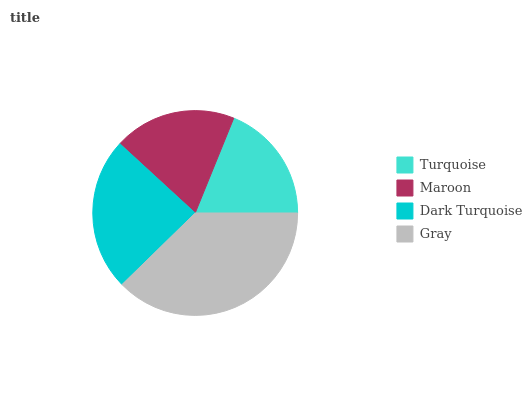Is Turquoise the minimum?
Answer yes or no. Yes. Is Gray the maximum?
Answer yes or no. Yes. Is Maroon the minimum?
Answer yes or no. No. Is Maroon the maximum?
Answer yes or no. No. Is Maroon greater than Turquoise?
Answer yes or no. Yes. Is Turquoise less than Maroon?
Answer yes or no. Yes. Is Turquoise greater than Maroon?
Answer yes or no. No. Is Maroon less than Turquoise?
Answer yes or no. No. Is Dark Turquoise the high median?
Answer yes or no. Yes. Is Maroon the low median?
Answer yes or no. Yes. Is Turquoise the high median?
Answer yes or no. No. Is Turquoise the low median?
Answer yes or no. No. 